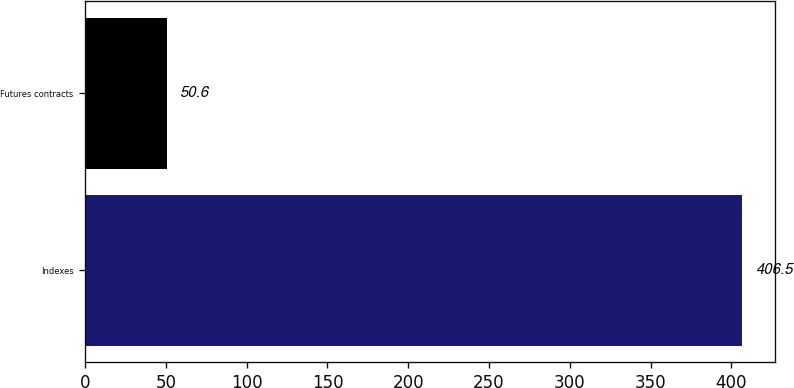Convert chart. <chart><loc_0><loc_0><loc_500><loc_500><bar_chart><fcel>Indexes<fcel>Futures contracts<nl><fcel>406.5<fcel>50.6<nl></chart> 